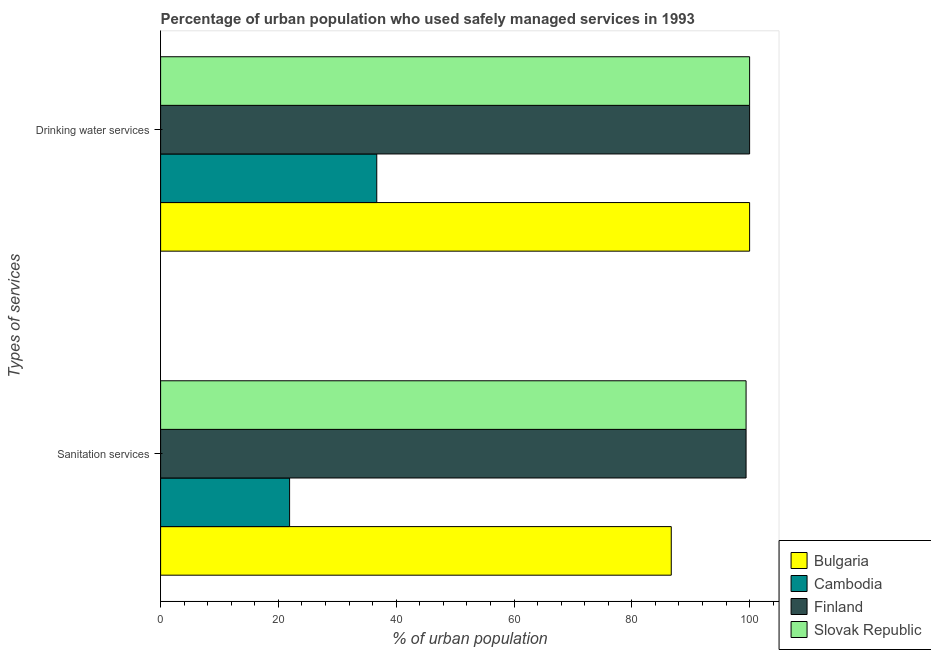How many different coloured bars are there?
Provide a short and direct response. 4. How many groups of bars are there?
Keep it short and to the point. 2. Are the number of bars on each tick of the Y-axis equal?
Provide a succinct answer. Yes. How many bars are there on the 1st tick from the top?
Your answer should be compact. 4. How many bars are there on the 1st tick from the bottom?
Offer a terse response. 4. What is the label of the 2nd group of bars from the top?
Your answer should be very brief. Sanitation services. Across all countries, what is the maximum percentage of urban population who used drinking water services?
Make the answer very short. 100. Across all countries, what is the minimum percentage of urban population who used drinking water services?
Ensure brevity in your answer.  36.7. In which country was the percentage of urban population who used drinking water services minimum?
Your response must be concise. Cambodia. What is the total percentage of urban population who used drinking water services in the graph?
Provide a short and direct response. 336.7. What is the difference between the percentage of urban population who used drinking water services in Cambodia and that in Slovak Republic?
Your response must be concise. -63.3. What is the difference between the percentage of urban population who used sanitation services in Cambodia and the percentage of urban population who used drinking water services in Bulgaria?
Provide a short and direct response. -78.1. What is the average percentage of urban population who used drinking water services per country?
Keep it short and to the point. 84.17. What is the difference between the percentage of urban population who used sanitation services and percentage of urban population who used drinking water services in Bulgaria?
Your answer should be very brief. -13.3. In how many countries, is the percentage of urban population who used drinking water services greater than 28 %?
Make the answer very short. 4. What is the ratio of the percentage of urban population who used drinking water services in Bulgaria to that in Finland?
Make the answer very short. 1. Is the percentage of urban population who used sanitation services in Bulgaria less than that in Cambodia?
Provide a short and direct response. No. What does the 4th bar from the bottom in Drinking water services represents?
Offer a very short reply. Slovak Republic. How many bars are there?
Make the answer very short. 8. Are all the bars in the graph horizontal?
Offer a terse response. Yes. How many countries are there in the graph?
Your answer should be compact. 4. What is the difference between two consecutive major ticks on the X-axis?
Your answer should be very brief. 20. Are the values on the major ticks of X-axis written in scientific E-notation?
Give a very brief answer. No. Does the graph contain any zero values?
Offer a terse response. No. Does the graph contain grids?
Ensure brevity in your answer.  No. How many legend labels are there?
Your answer should be very brief. 4. How are the legend labels stacked?
Make the answer very short. Vertical. What is the title of the graph?
Your answer should be very brief. Percentage of urban population who used safely managed services in 1993. What is the label or title of the X-axis?
Provide a succinct answer. % of urban population. What is the label or title of the Y-axis?
Provide a succinct answer. Types of services. What is the % of urban population in Bulgaria in Sanitation services?
Keep it short and to the point. 86.7. What is the % of urban population in Cambodia in Sanitation services?
Keep it short and to the point. 21.9. What is the % of urban population in Finland in Sanitation services?
Ensure brevity in your answer.  99.4. What is the % of urban population in Slovak Republic in Sanitation services?
Keep it short and to the point. 99.4. What is the % of urban population in Bulgaria in Drinking water services?
Your response must be concise. 100. What is the % of urban population of Cambodia in Drinking water services?
Keep it short and to the point. 36.7. What is the % of urban population in Slovak Republic in Drinking water services?
Provide a short and direct response. 100. Across all Types of services, what is the maximum % of urban population in Cambodia?
Make the answer very short. 36.7. Across all Types of services, what is the minimum % of urban population of Bulgaria?
Give a very brief answer. 86.7. Across all Types of services, what is the minimum % of urban population of Cambodia?
Make the answer very short. 21.9. Across all Types of services, what is the minimum % of urban population in Finland?
Offer a terse response. 99.4. Across all Types of services, what is the minimum % of urban population of Slovak Republic?
Keep it short and to the point. 99.4. What is the total % of urban population of Bulgaria in the graph?
Your answer should be compact. 186.7. What is the total % of urban population in Cambodia in the graph?
Provide a succinct answer. 58.6. What is the total % of urban population in Finland in the graph?
Keep it short and to the point. 199.4. What is the total % of urban population of Slovak Republic in the graph?
Ensure brevity in your answer.  199.4. What is the difference between the % of urban population of Cambodia in Sanitation services and that in Drinking water services?
Offer a very short reply. -14.8. What is the difference between the % of urban population of Slovak Republic in Sanitation services and that in Drinking water services?
Provide a succinct answer. -0.6. What is the difference between the % of urban population in Bulgaria in Sanitation services and the % of urban population in Finland in Drinking water services?
Your answer should be very brief. -13.3. What is the difference between the % of urban population of Bulgaria in Sanitation services and the % of urban population of Slovak Republic in Drinking water services?
Provide a short and direct response. -13.3. What is the difference between the % of urban population in Cambodia in Sanitation services and the % of urban population in Finland in Drinking water services?
Provide a short and direct response. -78.1. What is the difference between the % of urban population in Cambodia in Sanitation services and the % of urban population in Slovak Republic in Drinking water services?
Make the answer very short. -78.1. What is the difference between the % of urban population in Finland in Sanitation services and the % of urban population in Slovak Republic in Drinking water services?
Offer a terse response. -0.6. What is the average % of urban population of Bulgaria per Types of services?
Your response must be concise. 93.35. What is the average % of urban population of Cambodia per Types of services?
Make the answer very short. 29.3. What is the average % of urban population in Finland per Types of services?
Ensure brevity in your answer.  99.7. What is the average % of urban population of Slovak Republic per Types of services?
Offer a terse response. 99.7. What is the difference between the % of urban population of Bulgaria and % of urban population of Cambodia in Sanitation services?
Your answer should be very brief. 64.8. What is the difference between the % of urban population of Bulgaria and % of urban population of Slovak Republic in Sanitation services?
Give a very brief answer. -12.7. What is the difference between the % of urban population in Cambodia and % of urban population in Finland in Sanitation services?
Your answer should be compact. -77.5. What is the difference between the % of urban population of Cambodia and % of urban population of Slovak Republic in Sanitation services?
Your answer should be very brief. -77.5. What is the difference between the % of urban population in Bulgaria and % of urban population in Cambodia in Drinking water services?
Offer a terse response. 63.3. What is the difference between the % of urban population in Bulgaria and % of urban population in Slovak Republic in Drinking water services?
Your response must be concise. 0. What is the difference between the % of urban population in Cambodia and % of urban population in Finland in Drinking water services?
Your answer should be compact. -63.3. What is the difference between the % of urban population in Cambodia and % of urban population in Slovak Republic in Drinking water services?
Offer a very short reply. -63.3. What is the ratio of the % of urban population of Bulgaria in Sanitation services to that in Drinking water services?
Give a very brief answer. 0.87. What is the ratio of the % of urban population of Cambodia in Sanitation services to that in Drinking water services?
Your response must be concise. 0.6. What is the ratio of the % of urban population of Finland in Sanitation services to that in Drinking water services?
Your response must be concise. 0.99. What is the ratio of the % of urban population of Slovak Republic in Sanitation services to that in Drinking water services?
Offer a very short reply. 0.99. What is the difference between the highest and the second highest % of urban population in Bulgaria?
Your response must be concise. 13.3. What is the difference between the highest and the second highest % of urban population in Cambodia?
Ensure brevity in your answer.  14.8. What is the difference between the highest and the lowest % of urban population in Cambodia?
Ensure brevity in your answer.  14.8. 